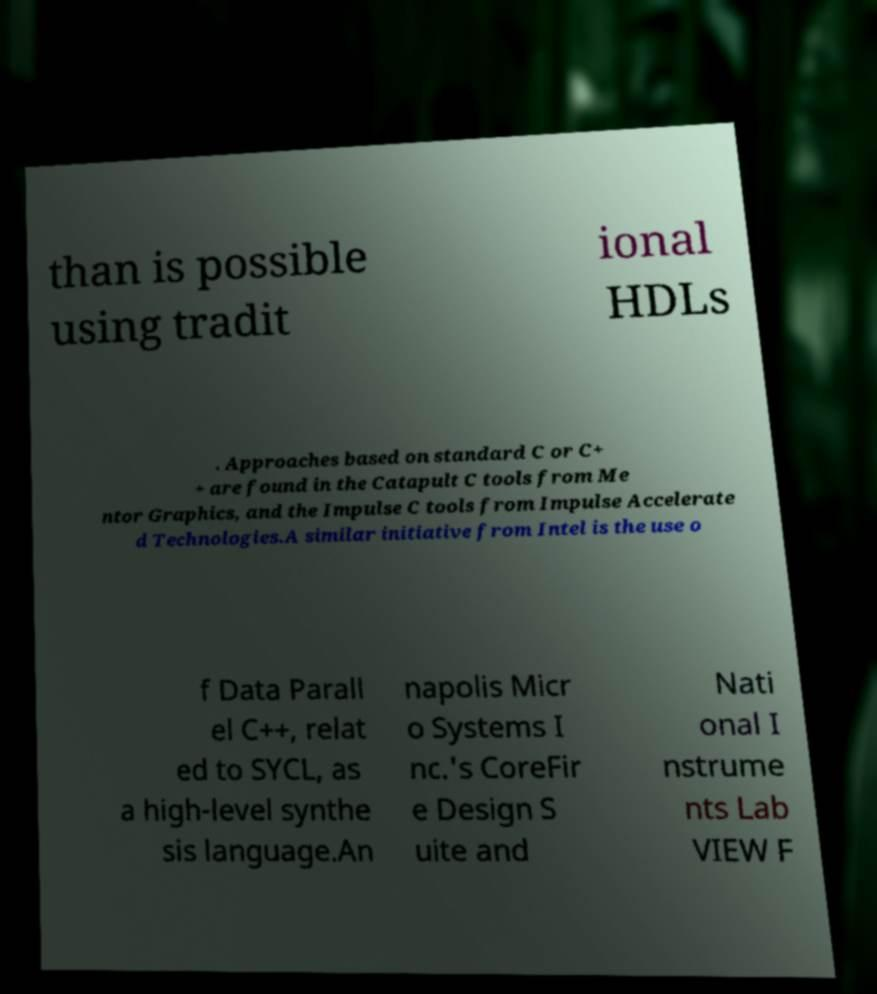There's text embedded in this image that I need extracted. Can you transcribe it verbatim? than is possible using tradit ional HDLs . Approaches based on standard C or C+ + are found in the Catapult C tools from Me ntor Graphics, and the Impulse C tools from Impulse Accelerate d Technologies.A similar initiative from Intel is the use o f Data Parall el C++, relat ed to SYCL, as a high-level synthe sis language.An napolis Micr o Systems I nc.'s CoreFir e Design S uite and Nati onal I nstrume nts Lab VIEW F 